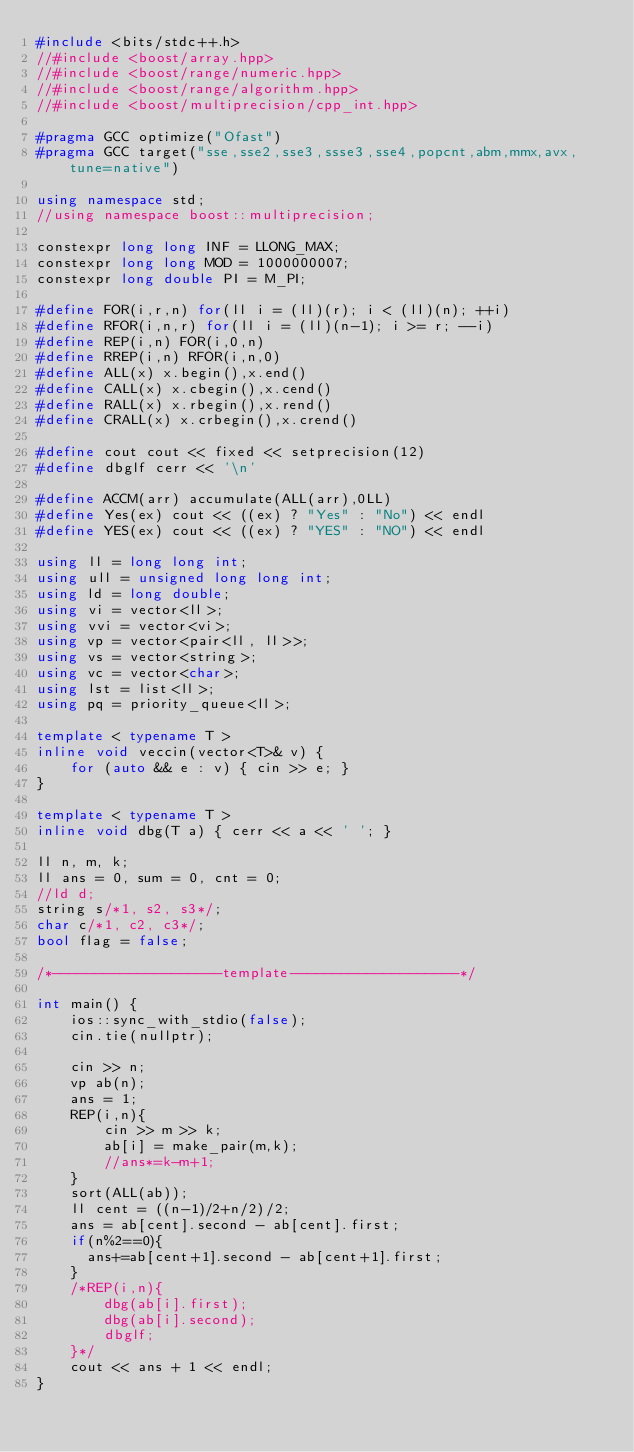Convert code to text. <code><loc_0><loc_0><loc_500><loc_500><_C++_>#include <bits/stdc++.h>
//#include <boost/array.hpp>
//#include <boost/range/numeric.hpp>
//#include <boost/range/algorithm.hpp>
//#include <boost/multiprecision/cpp_int.hpp>

#pragma GCC optimize("Ofast")
#pragma GCC target("sse,sse2,sse3,ssse3,sse4,popcnt,abm,mmx,avx,tune=native")

using namespace std;
//using namespace boost::multiprecision;

constexpr long long INF = LLONG_MAX;
constexpr long long MOD = 1000000007;
constexpr long double PI = M_PI;

#define FOR(i,r,n) for(ll i = (ll)(r); i < (ll)(n); ++i)
#define RFOR(i,n,r) for(ll i = (ll)(n-1); i >= r; --i)
#define REP(i,n) FOR(i,0,n)
#define RREP(i,n) RFOR(i,n,0)
#define ALL(x) x.begin(),x.end()
#define CALL(x) x.cbegin(),x.cend()
#define RALL(x) x.rbegin(),x.rend()
#define CRALL(x) x.crbegin(),x.crend()

#define cout cout << fixed << setprecision(12)
#define dbglf cerr << '\n'

#define ACCM(arr) accumulate(ALL(arr),0LL)
#define Yes(ex) cout << ((ex) ? "Yes" : "No") << endl
#define YES(ex) cout << ((ex) ? "YES" : "NO") << endl

using ll = long long int;
using ull = unsigned long long int;
using ld = long double;
using vi = vector<ll>;
using vvi = vector<vi>;
using vp = vector<pair<ll, ll>>;
using vs = vector<string>;
using vc = vector<char>;
using lst = list<ll>;
using pq = priority_queue<ll>;

template < typename T >
inline void veccin(vector<T>& v) {
    for (auto && e : v) { cin >> e; }
}

template < typename T >
inline void dbg(T a) { cerr << a << ' '; }

ll n, m, k;
ll ans = 0, sum = 0, cnt = 0;
//ld d;
string s/*1, s2, s3*/;
char c/*1, c2, c3*/;
bool flag = false;

/*--------------------template--------------------*/

int main() {
    ios::sync_with_stdio(false);
    cin.tie(nullptr);

    cin >> n;
	vp ab(n);
	ans = 1;
	REP(i,n){
    	cin >> m >> k;
    	ab[i] = make_pair(m,k);
    	//ans*=k-m+1;
    }
	sort(ALL(ab));
	ll cent = ((n-1)/2+n/2)/2;
	ans = ab[cent].second - ab[cent].first;
	if(n%2==0){
      ans+=ab[cent+1].second - ab[cent+1].first;
    }
	/*REP(i,n){
    	dbg(ab[i].first);
    	dbg(ab[i].second);
    	dbglf;
    }*/
    cout << ans + 1 << endl;
}
</code> 